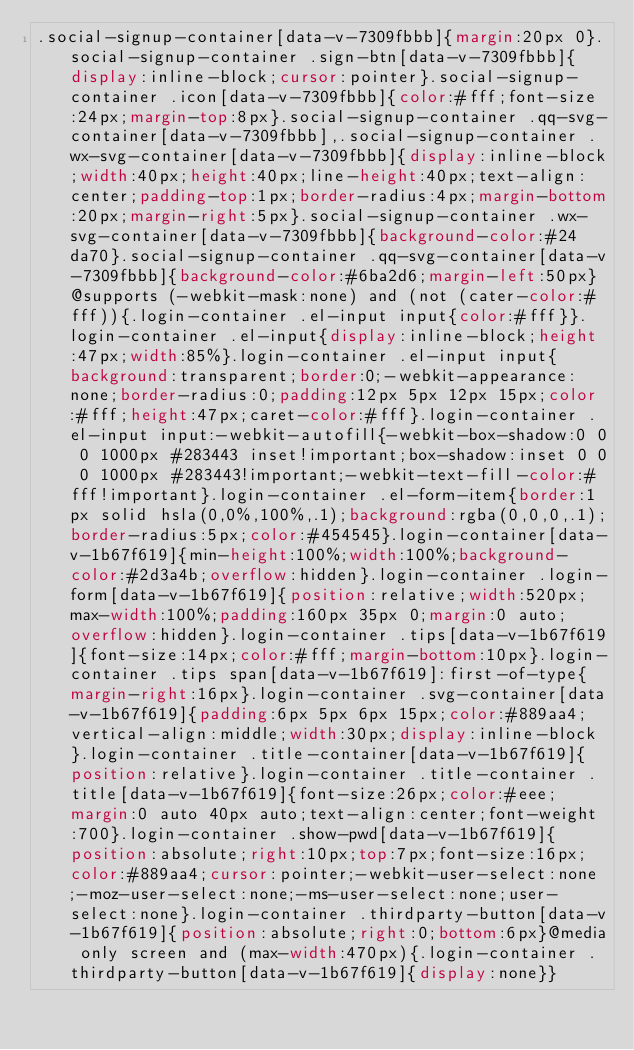<code> <loc_0><loc_0><loc_500><loc_500><_CSS_>.social-signup-container[data-v-7309fbbb]{margin:20px 0}.social-signup-container .sign-btn[data-v-7309fbbb]{display:inline-block;cursor:pointer}.social-signup-container .icon[data-v-7309fbbb]{color:#fff;font-size:24px;margin-top:8px}.social-signup-container .qq-svg-container[data-v-7309fbbb],.social-signup-container .wx-svg-container[data-v-7309fbbb]{display:inline-block;width:40px;height:40px;line-height:40px;text-align:center;padding-top:1px;border-radius:4px;margin-bottom:20px;margin-right:5px}.social-signup-container .wx-svg-container[data-v-7309fbbb]{background-color:#24da70}.social-signup-container .qq-svg-container[data-v-7309fbbb]{background-color:#6ba2d6;margin-left:50px}@supports (-webkit-mask:none) and (not (cater-color:#fff)){.login-container .el-input input{color:#fff}}.login-container .el-input{display:inline-block;height:47px;width:85%}.login-container .el-input input{background:transparent;border:0;-webkit-appearance:none;border-radius:0;padding:12px 5px 12px 15px;color:#fff;height:47px;caret-color:#fff}.login-container .el-input input:-webkit-autofill{-webkit-box-shadow:0 0 0 1000px #283443 inset!important;box-shadow:inset 0 0 0 1000px #283443!important;-webkit-text-fill-color:#fff!important}.login-container .el-form-item{border:1px solid hsla(0,0%,100%,.1);background:rgba(0,0,0,.1);border-radius:5px;color:#454545}.login-container[data-v-1b67f619]{min-height:100%;width:100%;background-color:#2d3a4b;overflow:hidden}.login-container .login-form[data-v-1b67f619]{position:relative;width:520px;max-width:100%;padding:160px 35px 0;margin:0 auto;overflow:hidden}.login-container .tips[data-v-1b67f619]{font-size:14px;color:#fff;margin-bottom:10px}.login-container .tips span[data-v-1b67f619]:first-of-type{margin-right:16px}.login-container .svg-container[data-v-1b67f619]{padding:6px 5px 6px 15px;color:#889aa4;vertical-align:middle;width:30px;display:inline-block}.login-container .title-container[data-v-1b67f619]{position:relative}.login-container .title-container .title[data-v-1b67f619]{font-size:26px;color:#eee;margin:0 auto 40px auto;text-align:center;font-weight:700}.login-container .show-pwd[data-v-1b67f619]{position:absolute;right:10px;top:7px;font-size:16px;color:#889aa4;cursor:pointer;-webkit-user-select:none;-moz-user-select:none;-ms-user-select:none;user-select:none}.login-container .thirdparty-button[data-v-1b67f619]{position:absolute;right:0;bottom:6px}@media only screen and (max-width:470px){.login-container .thirdparty-button[data-v-1b67f619]{display:none}}</code> 